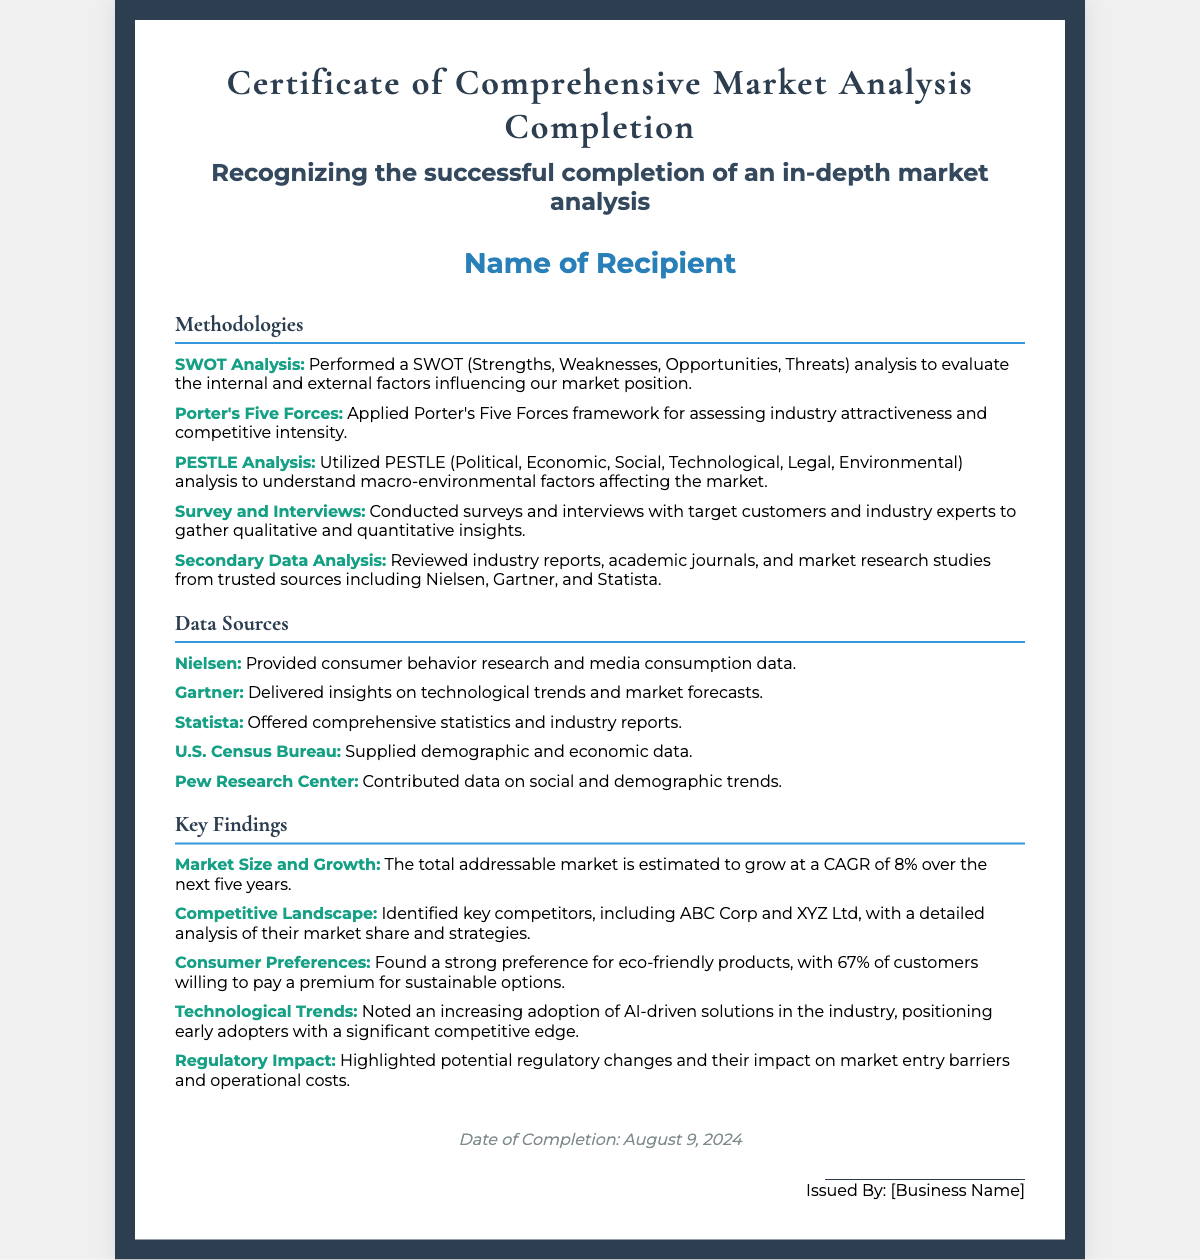What is the title of the certificate? The title of the certificate is prominently displayed at the top of the document.
Answer: Certificate of Comprehensive Market Analysis Completion What methodologies were utilized in the analysis? The document lists several methodologies used in the market analysis section.
Answer: SWOT Analysis, Porter's Five Forces, PESTLE Analysis, Survey and Interviews, Secondary Data Analysis Which source provides consumer behavior research? The sources section specifies various trusted organizations contributing to the analysis.
Answer: Nielsen What is the CAGR of the total addressable market? The key findings section provides a specific metric about market growth rates.
Answer: 8% Which competitor is identified as having a market share? The competitive landscape finding specifies names of key companies within the industry.
Answer: ABC Corp What percentage of customers prefer eco-friendly products? The key findings section provides consumer preference details with specific figures.
Answer: 67% What data source supplies demographic and economic data? The sources section lists data providers with specific types of information they offer.
Answer: U.S. Census Bureau When was the market analysis completed? The completion date is indicated in the footer of the document.
Answer: (date will be the current date when viewed) Who issued the certificate? The signature section identifies the issuer of the certificate.
Answer: [Business Name] 